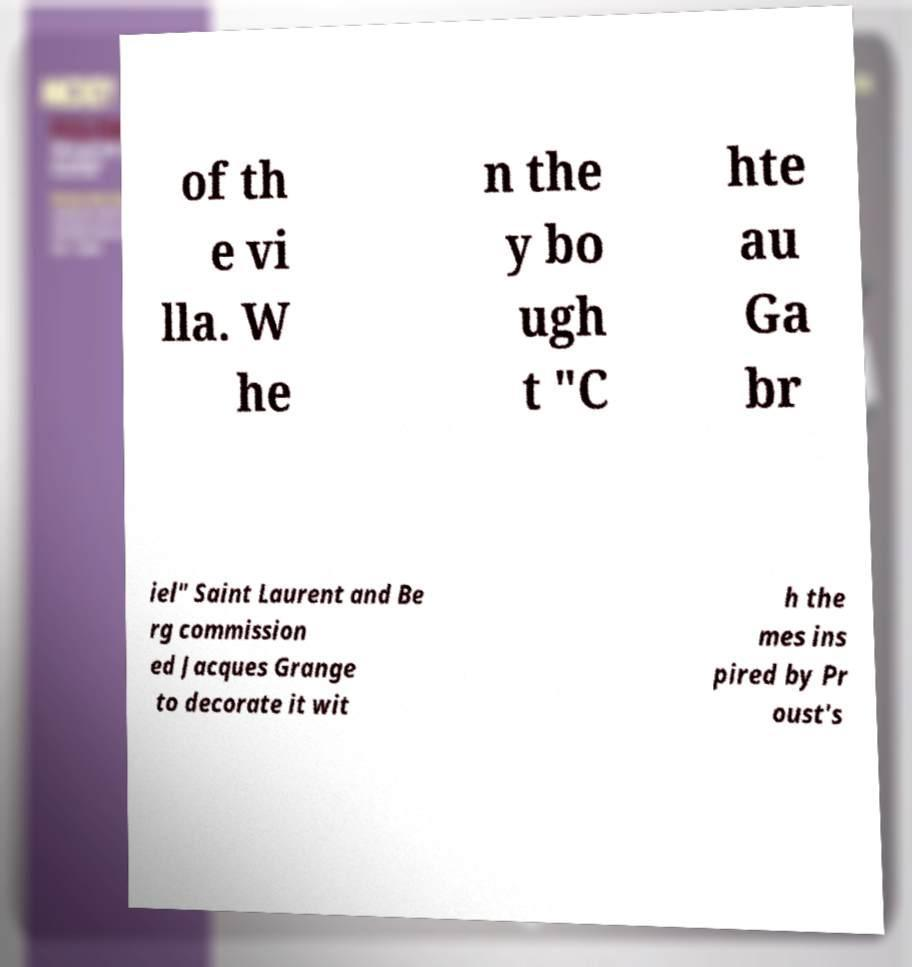What messages or text are displayed in this image? I need them in a readable, typed format. of th e vi lla. W he n the y bo ugh t "C hte au Ga br iel" Saint Laurent and Be rg commission ed Jacques Grange to decorate it wit h the mes ins pired by Pr oust's 